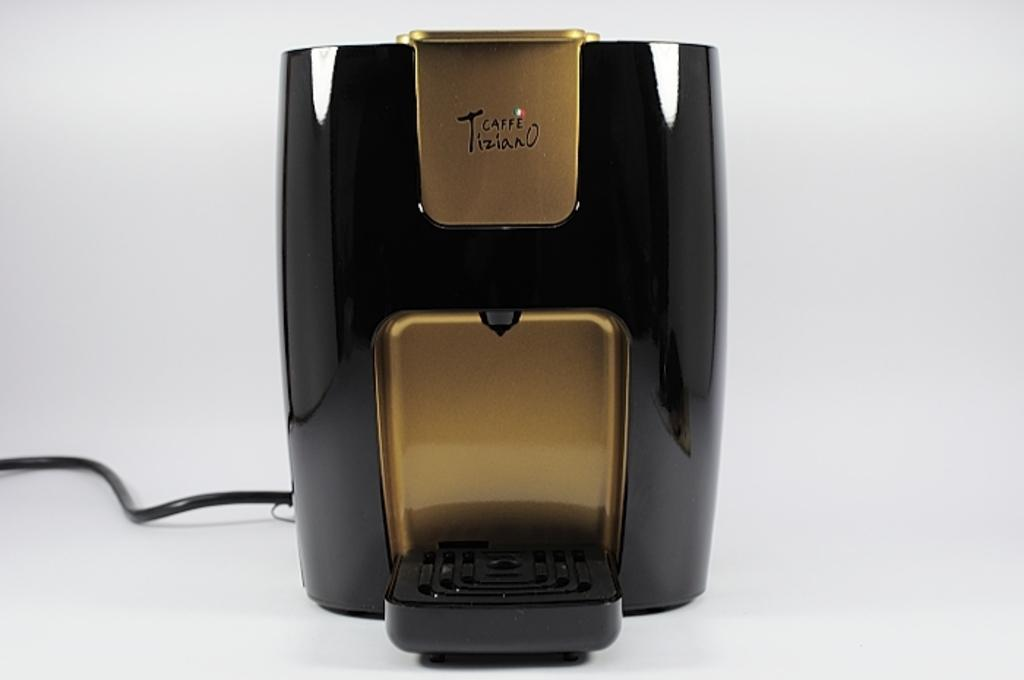What type of coffee maker is in the image? There is a drip coffee maker in the image. Does the drip coffee maker have any additional features? Yes, the drip coffee maker has a wire. Where is the drip coffee maker and wire located? The drip coffee maker and wire are placed on a surface. What is the price of the tray under the drip coffee maker in the image? There is no tray present in the image, so it is not possible to determine the price of a tray. 